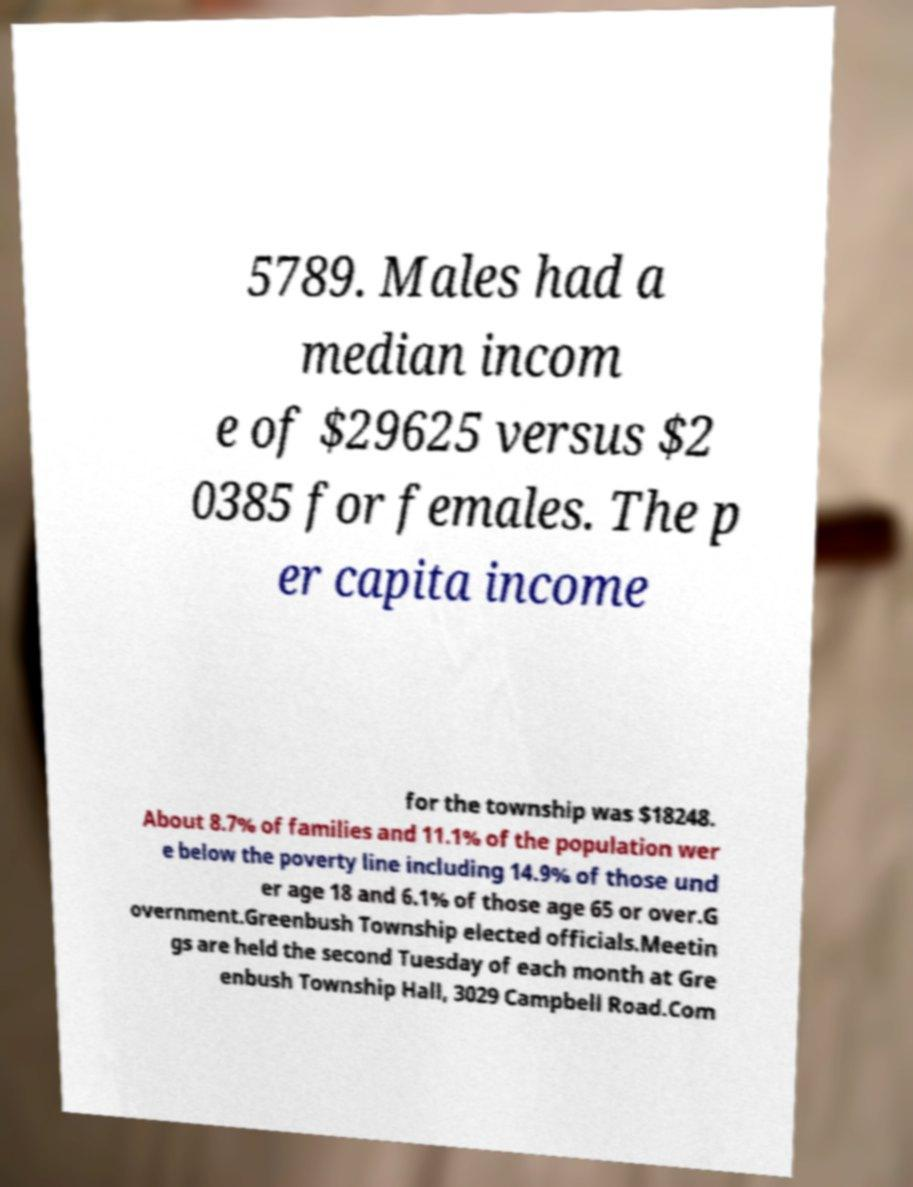Can you accurately transcribe the text from the provided image for me? 5789. Males had a median incom e of $29625 versus $2 0385 for females. The p er capita income for the township was $18248. About 8.7% of families and 11.1% of the population wer e below the poverty line including 14.9% of those und er age 18 and 6.1% of those age 65 or over.G overnment.Greenbush Township elected officials.Meetin gs are held the second Tuesday of each month at Gre enbush Township Hall, 3029 Campbell Road.Com 